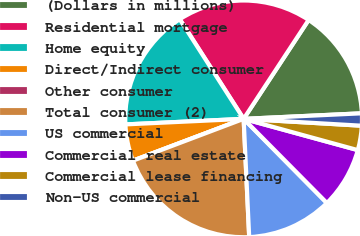Convert chart to OTSL. <chart><loc_0><loc_0><loc_500><loc_500><pie_chart><fcel>(Dollars in millions)<fcel>Residential mortgage<fcel>Home equity<fcel>Direct/Indirect consumer<fcel>Other consumer<fcel>Total consumer (2)<fcel>US commercial<fcel>Commercial real estate<fcel>Commercial lease financing<fcel>Non-US commercial<nl><fcel>15.0%<fcel>18.33%<fcel>16.67%<fcel>5.0%<fcel>0.0%<fcel>20.0%<fcel>11.67%<fcel>8.33%<fcel>3.33%<fcel>1.67%<nl></chart> 